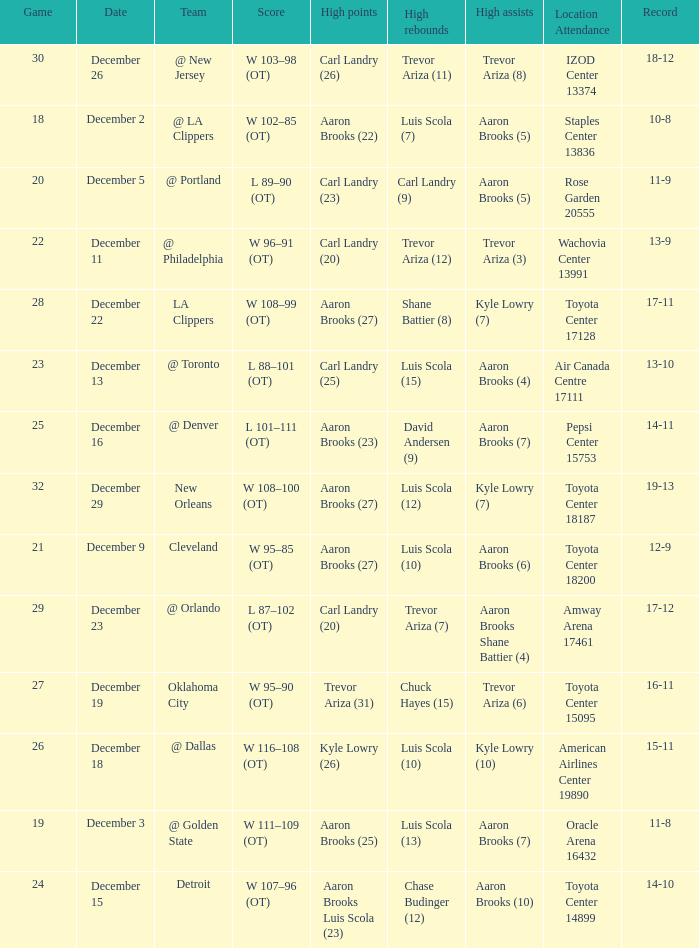What's the end score of the game where Shane Battier (8) did the high rebounds? W 108–99 (OT). Parse the table in full. {'header': ['Game', 'Date', 'Team', 'Score', 'High points', 'High rebounds', 'High assists', 'Location Attendance', 'Record'], 'rows': [['30', 'December 26', '@ New Jersey', 'W 103–98 (OT)', 'Carl Landry (26)', 'Trevor Ariza (11)', 'Trevor Ariza (8)', 'IZOD Center 13374', '18-12'], ['18', 'December 2', '@ LA Clippers', 'W 102–85 (OT)', 'Aaron Brooks (22)', 'Luis Scola (7)', 'Aaron Brooks (5)', 'Staples Center 13836', '10-8'], ['20', 'December 5', '@ Portland', 'L 89–90 (OT)', 'Carl Landry (23)', 'Carl Landry (9)', 'Aaron Brooks (5)', 'Rose Garden 20555', '11-9'], ['22', 'December 11', '@ Philadelphia', 'W 96–91 (OT)', 'Carl Landry (20)', 'Trevor Ariza (12)', 'Trevor Ariza (3)', 'Wachovia Center 13991', '13-9'], ['28', 'December 22', 'LA Clippers', 'W 108–99 (OT)', 'Aaron Brooks (27)', 'Shane Battier (8)', 'Kyle Lowry (7)', 'Toyota Center 17128', '17-11'], ['23', 'December 13', '@ Toronto', 'L 88–101 (OT)', 'Carl Landry (25)', 'Luis Scola (15)', 'Aaron Brooks (4)', 'Air Canada Centre 17111', '13-10'], ['25', 'December 16', '@ Denver', 'L 101–111 (OT)', 'Aaron Brooks (23)', 'David Andersen (9)', 'Aaron Brooks (7)', 'Pepsi Center 15753', '14-11'], ['32', 'December 29', 'New Orleans', 'W 108–100 (OT)', 'Aaron Brooks (27)', 'Luis Scola (12)', 'Kyle Lowry (7)', 'Toyota Center 18187', '19-13'], ['21', 'December 9', 'Cleveland', 'W 95–85 (OT)', 'Aaron Brooks (27)', 'Luis Scola (10)', 'Aaron Brooks (6)', 'Toyota Center 18200', '12-9'], ['29', 'December 23', '@ Orlando', 'L 87–102 (OT)', 'Carl Landry (20)', 'Trevor Ariza (7)', 'Aaron Brooks Shane Battier (4)', 'Amway Arena 17461', '17-12'], ['27', 'December 19', 'Oklahoma City', 'W 95–90 (OT)', 'Trevor Ariza (31)', 'Chuck Hayes (15)', 'Trevor Ariza (6)', 'Toyota Center 15095', '16-11'], ['26', 'December 18', '@ Dallas', 'W 116–108 (OT)', 'Kyle Lowry (26)', 'Luis Scola (10)', 'Kyle Lowry (10)', 'American Airlines Center 19890', '15-11'], ['19', 'December 3', '@ Golden State', 'W 111–109 (OT)', 'Aaron Brooks (25)', 'Luis Scola (13)', 'Aaron Brooks (7)', 'Oracle Arena 16432', '11-8'], ['24', 'December 15', 'Detroit', 'W 107–96 (OT)', 'Aaron Brooks Luis Scola (23)', 'Chase Budinger (12)', 'Aaron Brooks (10)', 'Toyota Center 14899', '14-10']]} 